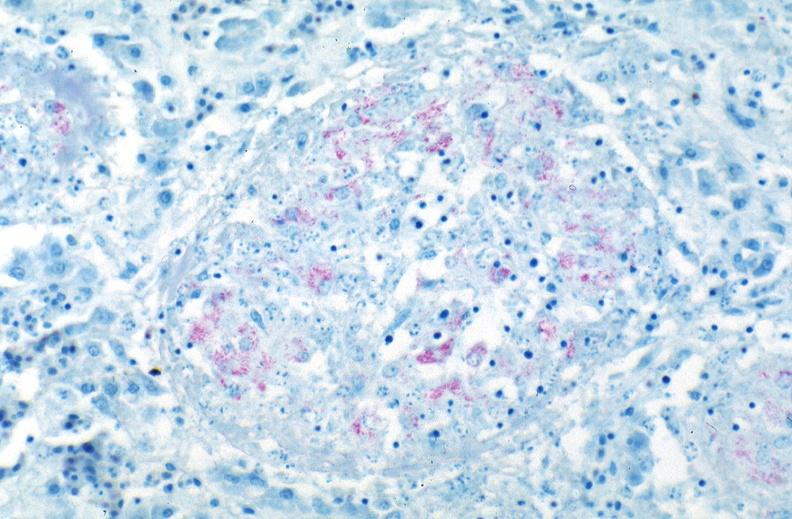s hyperplasia median bar present?
Answer the question using a single word or phrase. No 